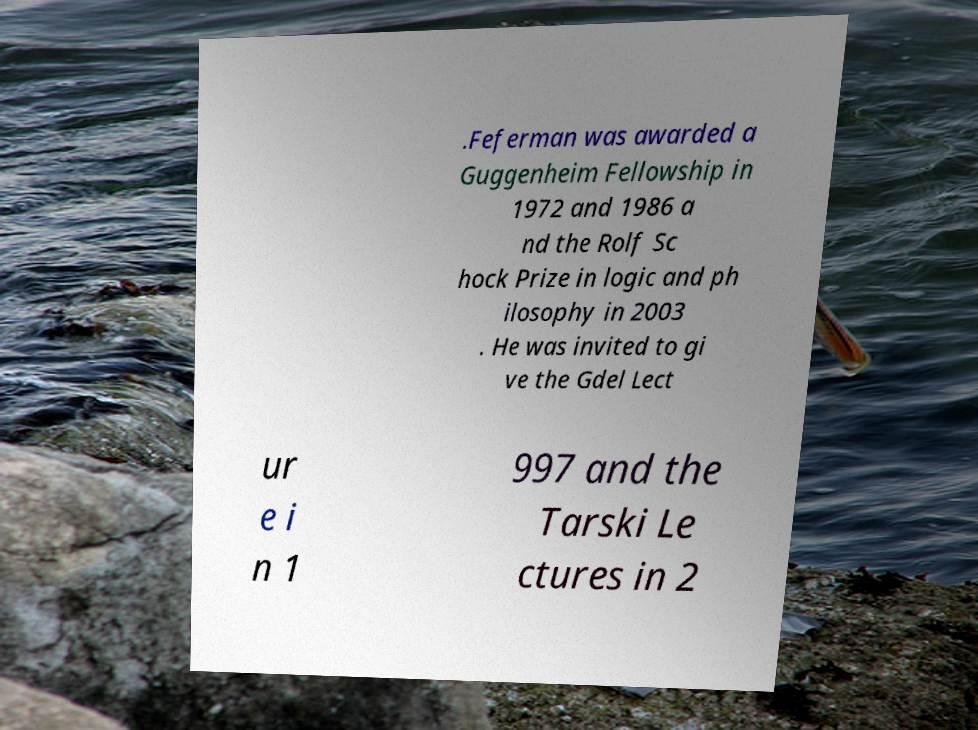Please identify and transcribe the text found in this image. .Feferman was awarded a Guggenheim Fellowship in 1972 and 1986 a nd the Rolf Sc hock Prize in logic and ph ilosophy in 2003 . He was invited to gi ve the Gdel Lect ur e i n 1 997 and the Tarski Le ctures in 2 